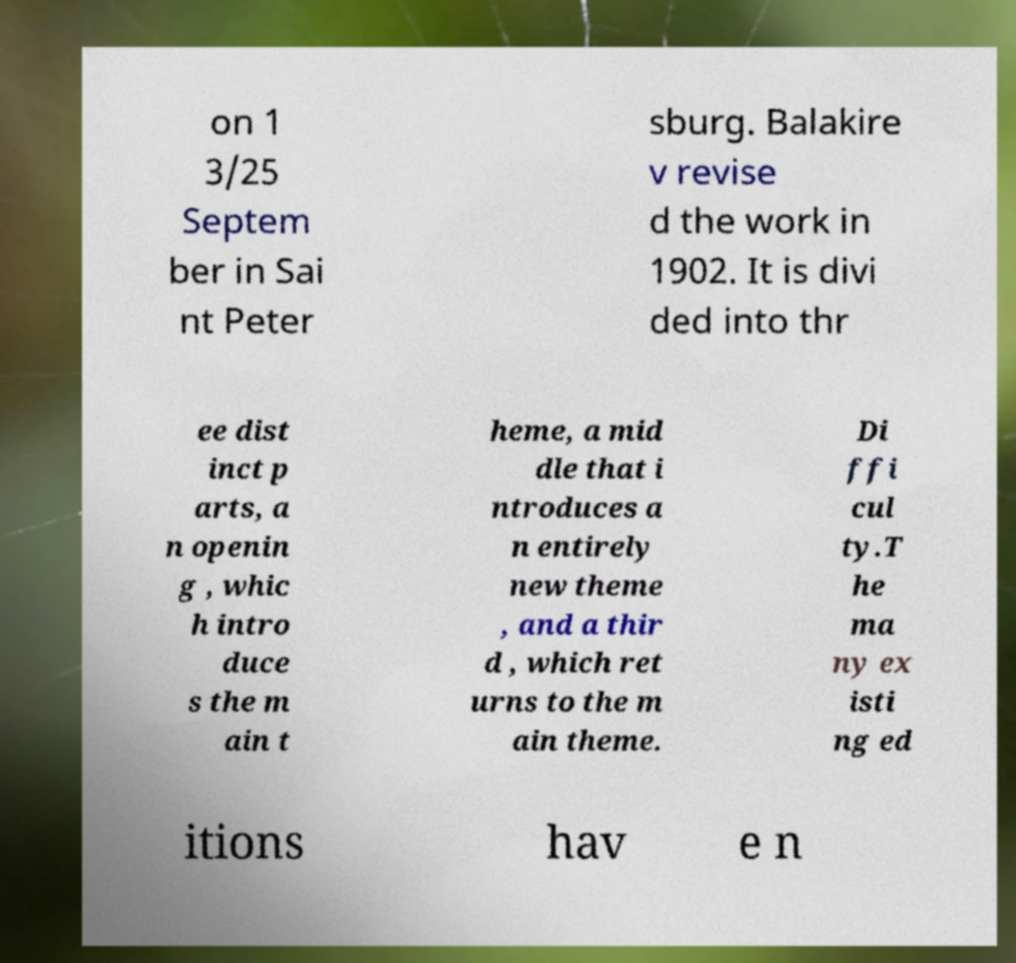Please read and relay the text visible in this image. What does it say? on 1 3/25 Septem ber in Sai nt Peter sburg. Balakire v revise d the work in 1902. It is divi ded into thr ee dist inct p arts, a n openin g , whic h intro duce s the m ain t heme, a mid dle that i ntroduces a n entirely new theme , and a thir d , which ret urns to the m ain theme. Di ffi cul ty.T he ma ny ex isti ng ed itions hav e n 